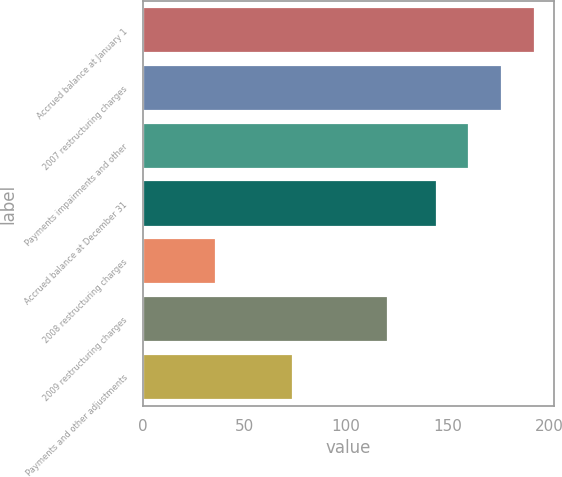Convert chart. <chart><loc_0><loc_0><loc_500><loc_500><bar_chart><fcel>Accrued balance at January 1<fcel>2007 restructuring charges<fcel>Payments impairments and other<fcel>Accrued balance at December 31<fcel>2008 restructuring charges<fcel>2009 restructuring charges<fcel>Payments and other adjustments<nl><fcel>193<fcel>176.6<fcel>160.8<fcel>145<fcel>36<fcel>120.8<fcel>74<nl></chart> 